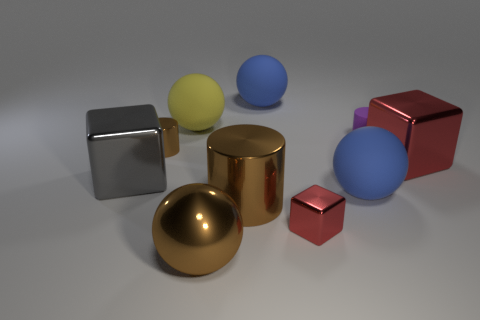What number of objects are either rubber cylinders or tiny shiny balls?
Offer a very short reply. 1. There is a small cylinder that is made of the same material as the tiny cube; what is its color?
Give a very brief answer. Brown. Do the large blue rubber thing in front of the rubber cylinder and the big red metal thing have the same shape?
Your response must be concise. No. How many things are either large matte balls in front of the small brown metal cylinder or red blocks that are on the left side of the large red metallic object?
Give a very brief answer. 2. There is another small object that is the same shape as the purple thing; what is its color?
Give a very brief answer. Brown. Are there any other things that have the same shape as the large yellow object?
Provide a succinct answer. Yes. Does the gray shiny thing have the same shape as the brown metal object that is right of the large brown metallic ball?
Your answer should be compact. No. What material is the tiny red cube?
Your answer should be compact. Metal. There is another metal thing that is the same shape as the tiny brown thing; what is its size?
Offer a terse response. Large. What number of other objects are there of the same material as the yellow sphere?
Offer a very short reply. 3. 